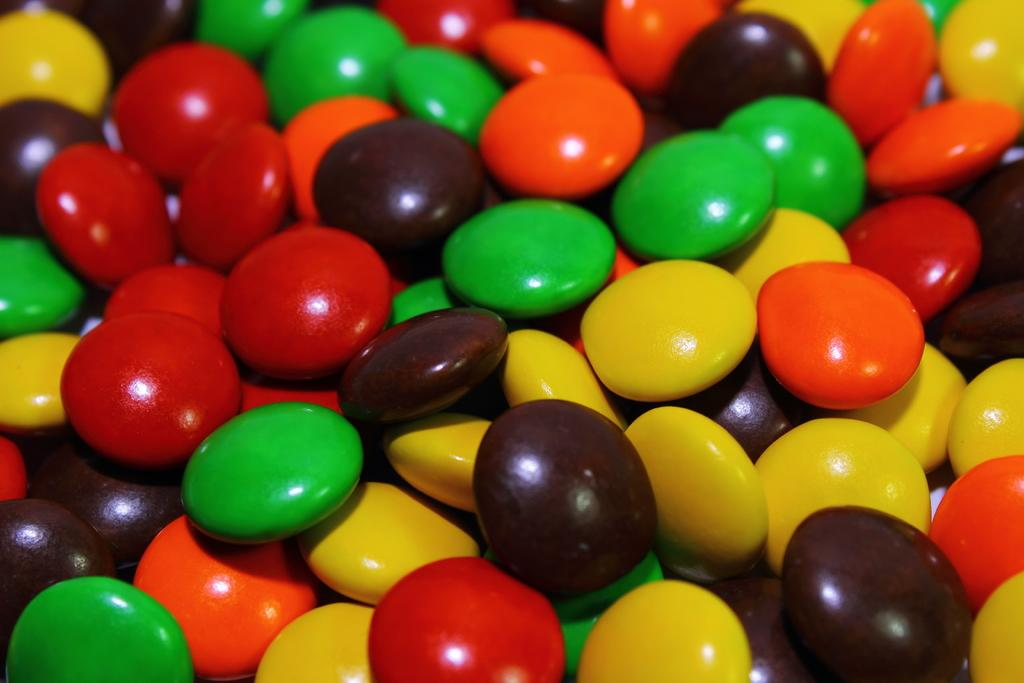What type of food is present in the image? There are chocolate buttons in the image. Can you describe the appearance of the chocolate buttons? The chocolate buttons have different colors. Where is the gun located in the image? There is no gun present in the image. What type of pickle can be seen in the image? There is no pickle present in the image. 